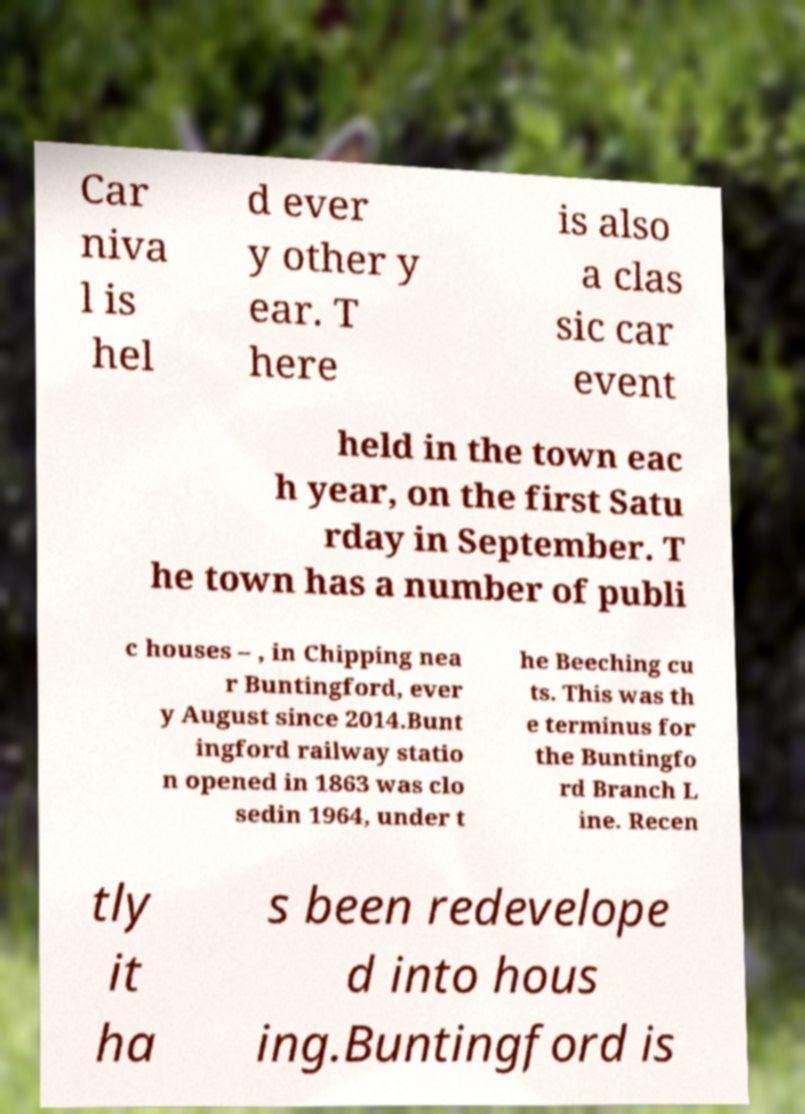Can you read and provide the text displayed in the image?This photo seems to have some interesting text. Can you extract and type it out for me? Car niva l is hel d ever y other y ear. T here is also a clas sic car event held in the town eac h year, on the first Satu rday in September. T he town has a number of publi c houses – , in Chipping nea r Buntingford, ever y August since 2014.Bunt ingford railway statio n opened in 1863 was clo sedin 1964, under t he Beeching cu ts. This was th e terminus for the Buntingfo rd Branch L ine. Recen tly it ha s been redevelope d into hous ing.Buntingford is 